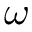<formula> <loc_0><loc_0><loc_500><loc_500>\omega</formula> 